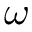<formula> <loc_0><loc_0><loc_500><loc_500>\omega</formula> 